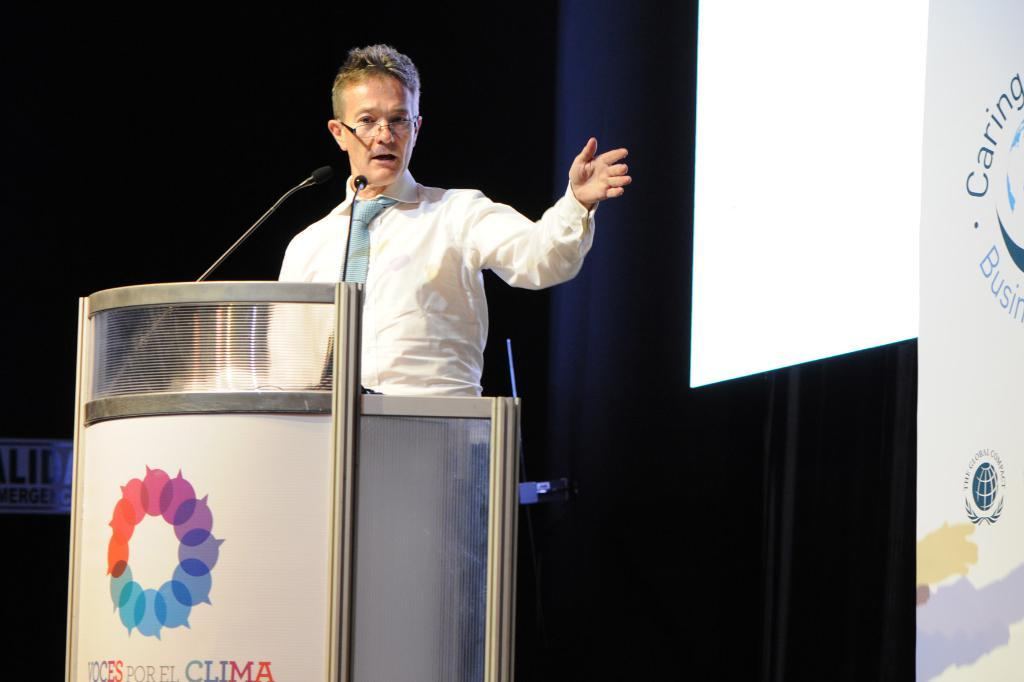<image>
Render a clear and concise summary of the photo. Person giving a speech behind a podium that says CLIMA. 